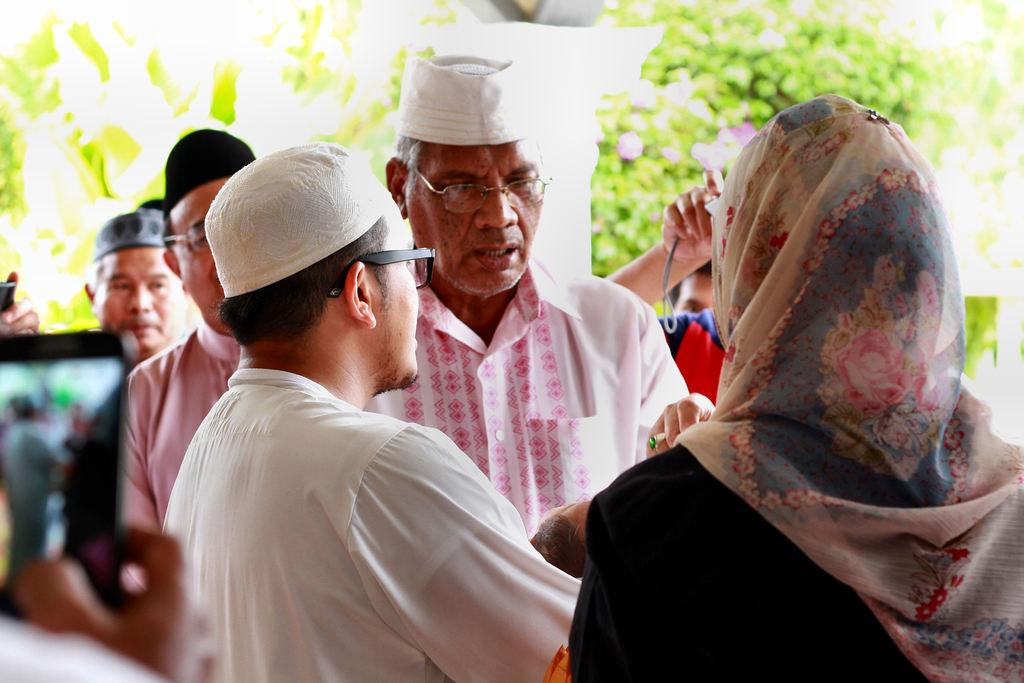How many people are in the image? There is a group of people in the image, but the exact number is not specified. What are the people in the image doing? The people are standing together and talking among themselves. Are any of the people in the image using any specific objects? Some people are using cameras in the image. What is located behind the group of people? There is a pillar behind the group of people. What type of natural elements can be seen in the image? There are trees visible in the image. What is the acoustics like in the image? The provided facts do not give any information about the acoustics in the image. Is there a protest happening in the image? There is no indication of a protest in the image; the people are simply standing together and talking among themselves. 